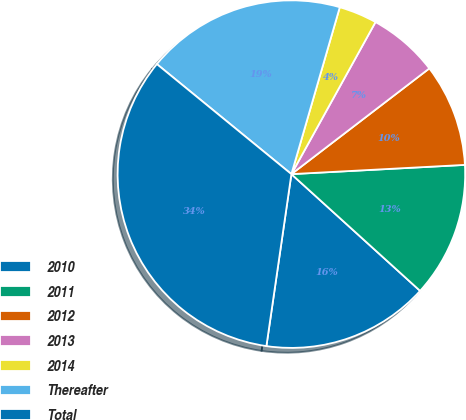Convert chart. <chart><loc_0><loc_0><loc_500><loc_500><pie_chart><fcel>2010<fcel>2011<fcel>2012<fcel>2013<fcel>2014<fcel>Thereafter<fcel>Total<nl><fcel>15.57%<fcel>12.57%<fcel>9.56%<fcel>6.55%<fcel>3.55%<fcel>18.58%<fcel>33.61%<nl></chart> 